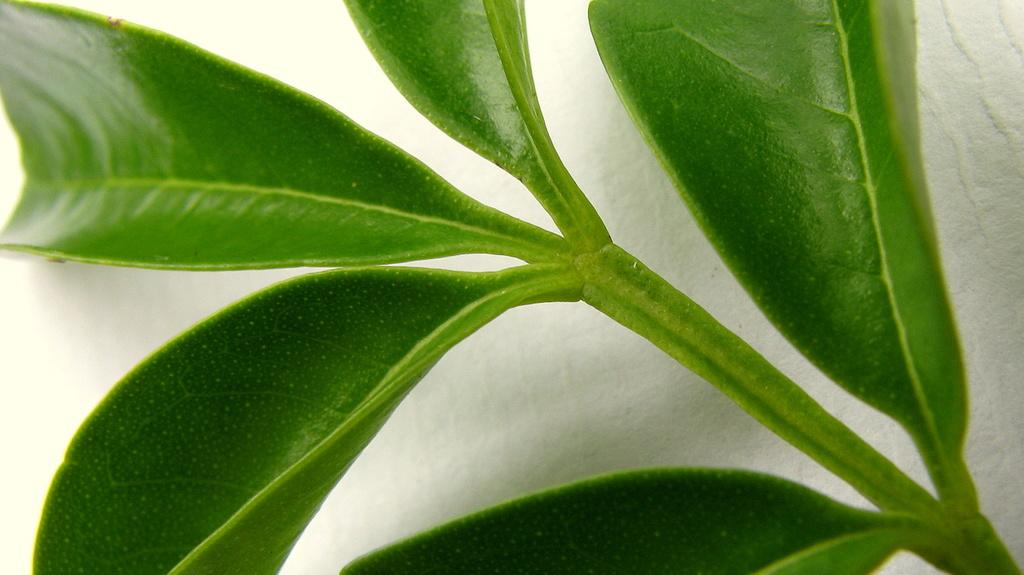What type of vegetation can be seen in the image? There are leaves in the image. What color is the background of the image? The background of the image is white. What type of pies are being served in the image? There are no pies present in the image; it only features leaves and a white background. 